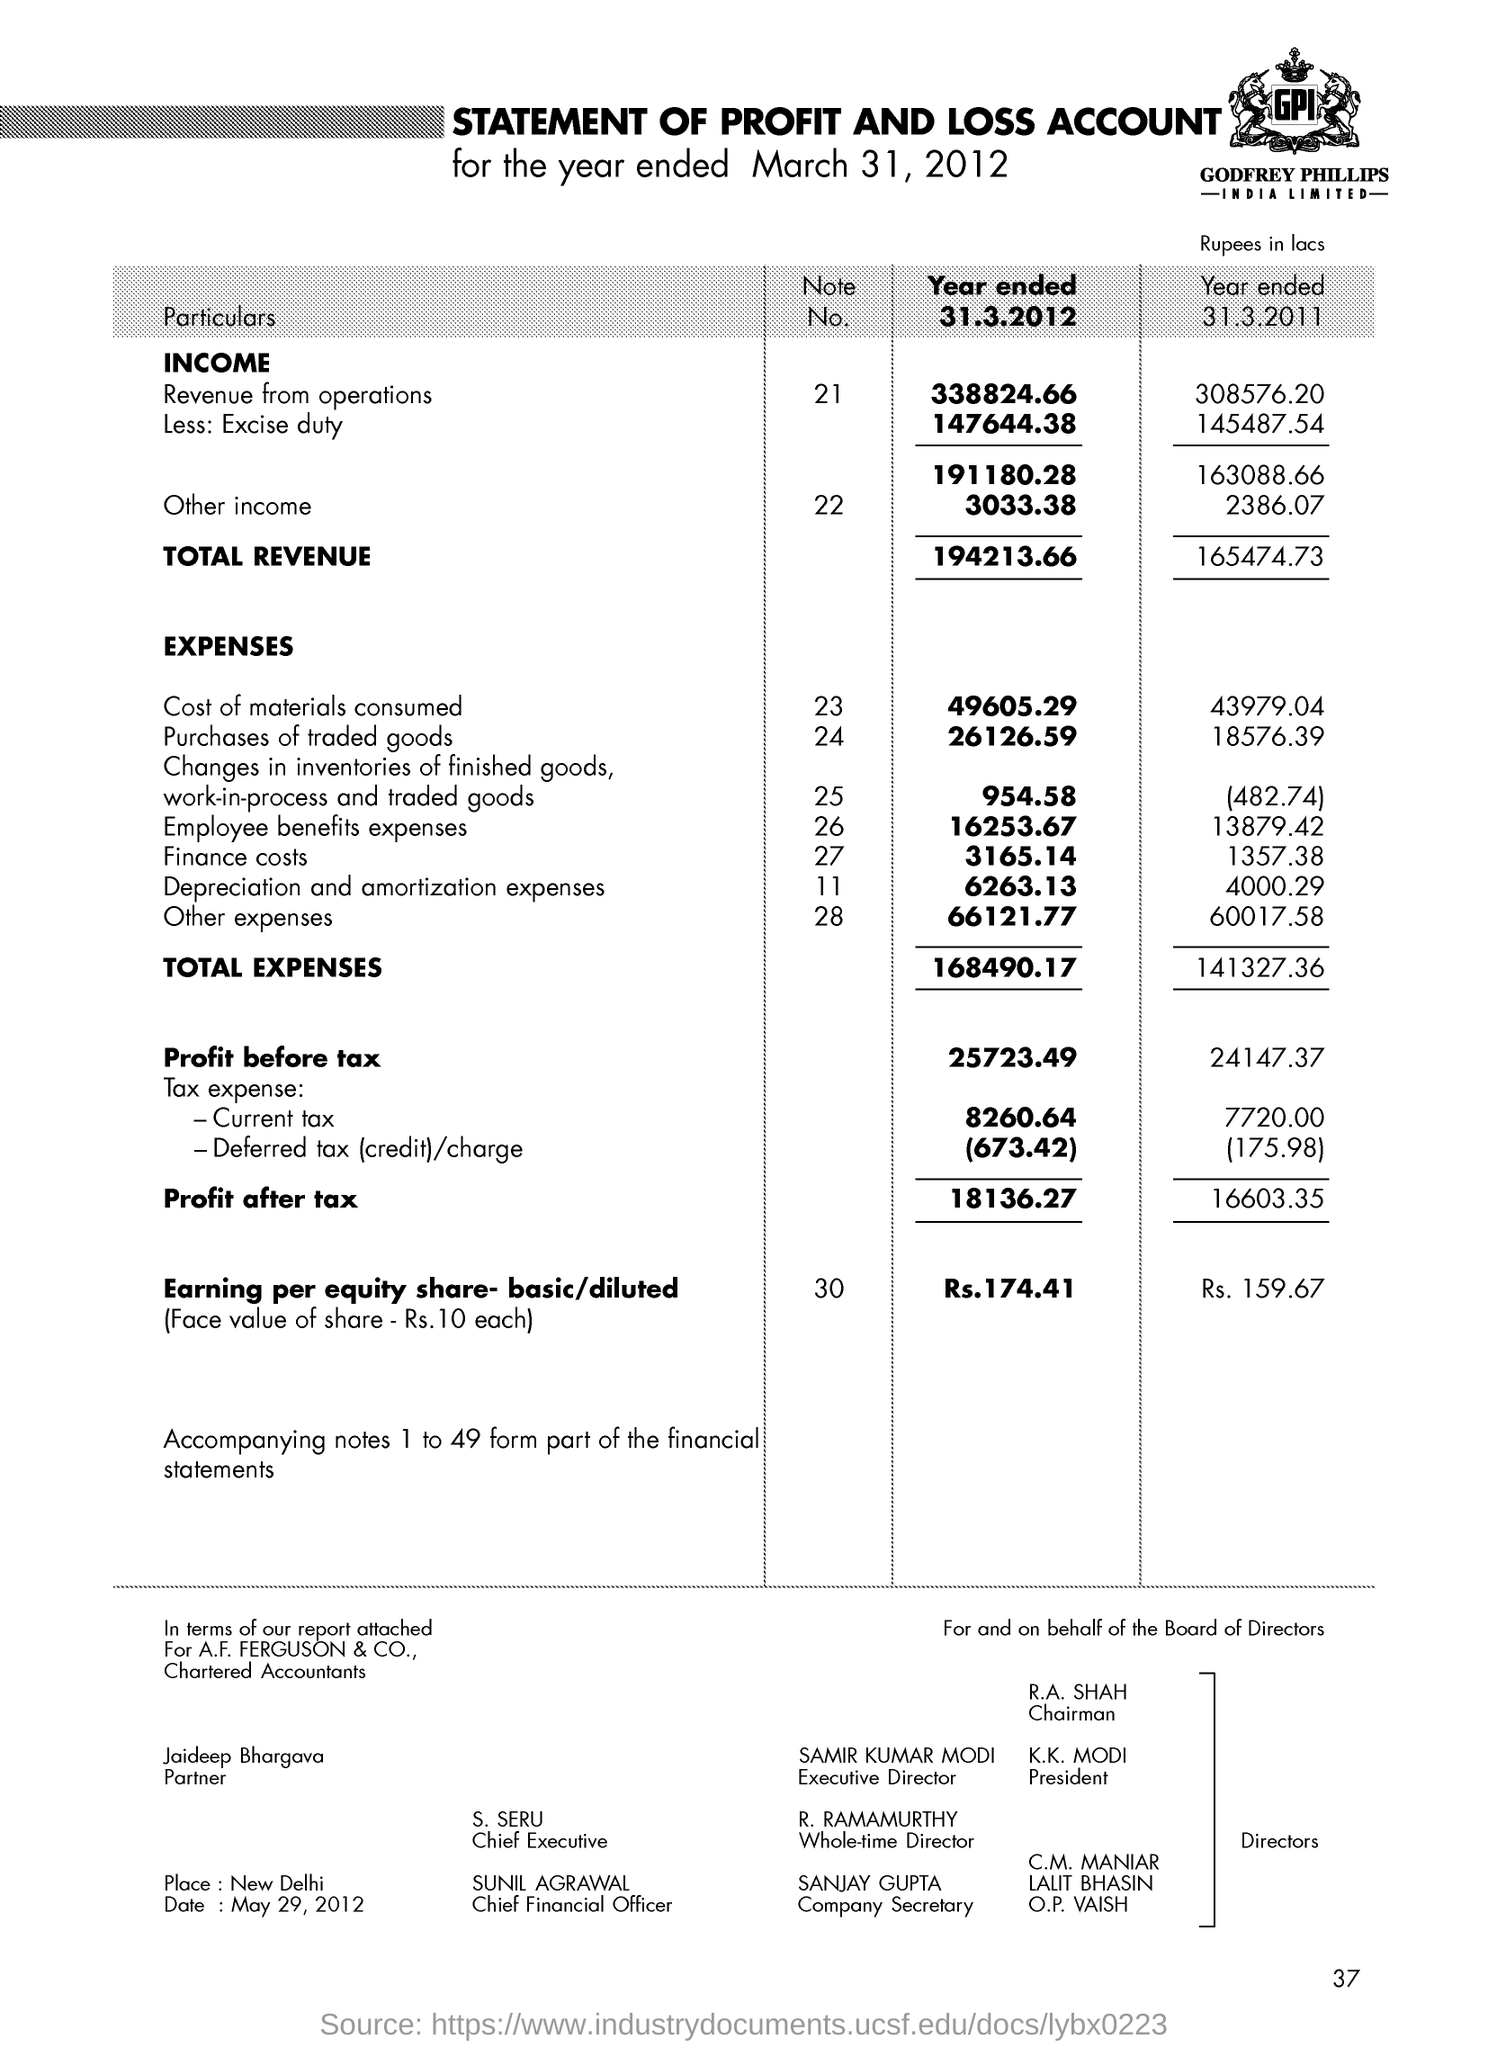What is the total revenue of the income as on year ended 31.3.2012
Your answer should be compact. 194213.66. Who is the president ?
Your answer should be compact. K.k. modi. Who is the chief executive ?
Ensure brevity in your answer.  S.SERU. What is the profit after tax for the year ended 31.3.2012
Provide a succinct answer. 18136.27. What is the profit after tax for the year ended 31.3.2011
Your answer should be very brief. 16603.35. What is the note no for the other income ?
Provide a succinct answer. 22. What is the income for the revenue from operations as on year ended 31.3.2012
Offer a terse response. 338824.66. What is the note no for earning per equity share -basic /diluted ?
Offer a very short reply. 30. Who is the partner ?
Your answer should be compact. Jaideep bhargava. 